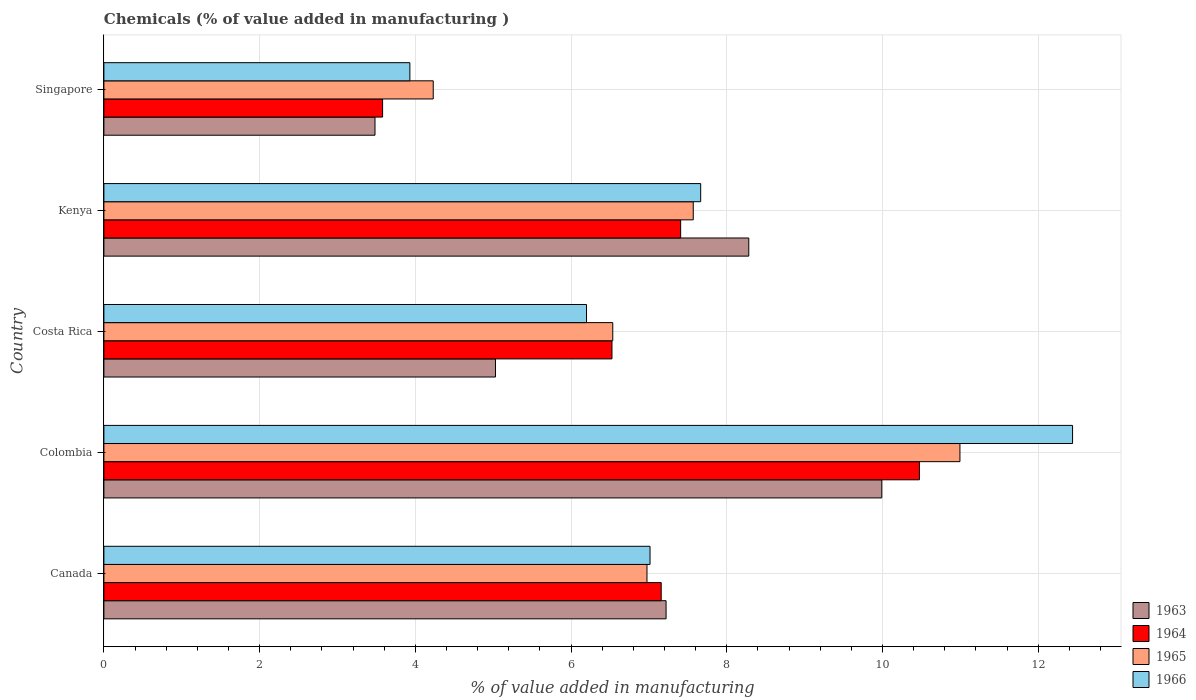How many different coloured bars are there?
Your answer should be very brief. 4. How many groups of bars are there?
Ensure brevity in your answer.  5. Are the number of bars per tick equal to the number of legend labels?
Provide a succinct answer. Yes. How many bars are there on the 5th tick from the bottom?
Offer a very short reply. 4. What is the label of the 1st group of bars from the top?
Provide a short and direct response. Singapore. In how many cases, is the number of bars for a given country not equal to the number of legend labels?
Provide a short and direct response. 0. What is the value added in manufacturing chemicals in 1964 in Canada?
Your response must be concise. 7.16. Across all countries, what is the maximum value added in manufacturing chemicals in 1965?
Keep it short and to the point. 10.99. Across all countries, what is the minimum value added in manufacturing chemicals in 1965?
Your answer should be very brief. 4.23. In which country was the value added in manufacturing chemicals in 1963 minimum?
Provide a succinct answer. Singapore. What is the total value added in manufacturing chemicals in 1965 in the graph?
Your answer should be very brief. 36.31. What is the difference between the value added in manufacturing chemicals in 1966 in Canada and that in Kenya?
Your answer should be very brief. -0.65. What is the difference between the value added in manufacturing chemicals in 1966 in Kenya and the value added in manufacturing chemicals in 1965 in Canada?
Your answer should be very brief. 0.69. What is the average value added in manufacturing chemicals in 1965 per country?
Your answer should be compact. 7.26. What is the difference between the value added in manufacturing chemicals in 1965 and value added in manufacturing chemicals in 1966 in Kenya?
Your response must be concise. -0.1. What is the ratio of the value added in manufacturing chemicals in 1966 in Canada to that in Colombia?
Offer a terse response. 0.56. Is the value added in manufacturing chemicals in 1964 in Canada less than that in Costa Rica?
Provide a succinct answer. No. What is the difference between the highest and the second highest value added in manufacturing chemicals in 1963?
Offer a very short reply. 1.71. What is the difference between the highest and the lowest value added in manufacturing chemicals in 1963?
Provide a short and direct response. 6.51. Is it the case that in every country, the sum of the value added in manufacturing chemicals in 1965 and value added in manufacturing chemicals in 1963 is greater than the sum of value added in manufacturing chemicals in 1964 and value added in manufacturing chemicals in 1966?
Your answer should be very brief. No. What does the 2nd bar from the top in Costa Rica represents?
Keep it short and to the point. 1965. What does the 1st bar from the bottom in Kenya represents?
Your answer should be compact. 1963. Are all the bars in the graph horizontal?
Offer a terse response. Yes. What is the difference between two consecutive major ticks on the X-axis?
Your answer should be very brief. 2. Are the values on the major ticks of X-axis written in scientific E-notation?
Provide a short and direct response. No. Does the graph contain any zero values?
Give a very brief answer. No. Where does the legend appear in the graph?
Your response must be concise. Bottom right. How are the legend labels stacked?
Make the answer very short. Vertical. What is the title of the graph?
Give a very brief answer. Chemicals (% of value added in manufacturing ). Does "1999" appear as one of the legend labels in the graph?
Provide a succinct answer. No. What is the label or title of the X-axis?
Provide a succinct answer. % of value added in manufacturing. What is the % of value added in manufacturing in 1963 in Canada?
Offer a very short reply. 7.22. What is the % of value added in manufacturing of 1964 in Canada?
Provide a short and direct response. 7.16. What is the % of value added in manufacturing of 1965 in Canada?
Your response must be concise. 6.98. What is the % of value added in manufacturing in 1966 in Canada?
Your response must be concise. 7.01. What is the % of value added in manufacturing in 1963 in Colombia?
Offer a terse response. 9.99. What is the % of value added in manufacturing in 1964 in Colombia?
Give a very brief answer. 10.47. What is the % of value added in manufacturing in 1965 in Colombia?
Offer a terse response. 10.99. What is the % of value added in manufacturing of 1966 in Colombia?
Offer a terse response. 12.44. What is the % of value added in manufacturing of 1963 in Costa Rica?
Ensure brevity in your answer.  5.03. What is the % of value added in manufacturing in 1964 in Costa Rica?
Offer a terse response. 6.53. What is the % of value added in manufacturing in 1965 in Costa Rica?
Your response must be concise. 6.54. What is the % of value added in manufacturing in 1966 in Costa Rica?
Your answer should be compact. 6.2. What is the % of value added in manufacturing in 1963 in Kenya?
Offer a terse response. 8.28. What is the % of value added in manufacturing of 1964 in Kenya?
Provide a succinct answer. 7.41. What is the % of value added in manufacturing in 1965 in Kenya?
Provide a succinct answer. 7.57. What is the % of value added in manufacturing of 1966 in Kenya?
Make the answer very short. 7.67. What is the % of value added in manufacturing of 1963 in Singapore?
Provide a short and direct response. 3.48. What is the % of value added in manufacturing in 1964 in Singapore?
Your response must be concise. 3.58. What is the % of value added in manufacturing of 1965 in Singapore?
Provide a short and direct response. 4.23. What is the % of value added in manufacturing of 1966 in Singapore?
Keep it short and to the point. 3.93. Across all countries, what is the maximum % of value added in manufacturing of 1963?
Make the answer very short. 9.99. Across all countries, what is the maximum % of value added in manufacturing in 1964?
Your answer should be very brief. 10.47. Across all countries, what is the maximum % of value added in manufacturing in 1965?
Keep it short and to the point. 10.99. Across all countries, what is the maximum % of value added in manufacturing in 1966?
Make the answer very short. 12.44. Across all countries, what is the minimum % of value added in manufacturing of 1963?
Your response must be concise. 3.48. Across all countries, what is the minimum % of value added in manufacturing of 1964?
Offer a terse response. 3.58. Across all countries, what is the minimum % of value added in manufacturing of 1965?
Your answer should be compact. 4.23. Across all countries, what is the minimum % of value added in manufacturing in 1966?
Give a very brief answer. 3.93. What is the total % of value added in manufacturing of 1963 in the graph?
Offer a very short reply. 34.01. What is the total % of value added in manufacturing in 1964 in the graph?
Your answer should be very brief. 35.15. What is the total % of value added in manufacturing of 1965 in the graph?
Offer a terse response. 36.31. What is the total % of value added in manufacturing in 1966 in the graph?
Provide a short and direct response. 37.25. What is the difference between the % of value added in manufacturing of 1963 in Canada and that in Colombia?
Your answer should be compact. -2.77. What is the difference between the % of value added in manufacturing of 1964 in Canada and that in Colombia?
Your answer should be compact. -3.32. What is the difference between the % of value added in manufacturing in 1965 in Canada and that in Colombia?
Make the answer very short. -4.02. What is the difference between the % of value added in manufacturing of 1966 in Canada and that in Colombia?
Provide a succinct answer. -5.43. What is the difference between the % of value added in manufacturing of 1963 in Canada and that in Costa Rica?
Keep it short and to the point. 2.19. What is the difference between the % of value added in manufacturing of 1964 in Canada and that in Costa Rica?
Your answer should be compact. 0.63. What is the difference between the % of value added in manufacturing of 1965 in Canada and that in Costa Rica?
Make the answer very short. 0.44. What is the difference between the % of value added in manufacturing of 1966 in Canada and that in Costa Rica?
Keep it short and to the point. 0.82. What is the difference between the % of value added in manufacturing of 1963 in Canada and that in Kenya?
Your response must be concise. -1.06. What is the difference between the % of value added in manufacturing of 1964 in Canada and that in Kenya?
Make the answer very short. -0.25. What is the difference between the % of value added in manufacturing of 1965 in Canada and that in Kenya?
Your answer should be very brief. -0.59. What is the difference between the % of value added in manufacturing in 1966 in Canada and that in Kenya?
Your answer should be very brief. -0.65. What is the difference between the % of value added in manufacturing in 1963 in Canada and that in Singapore?
Offer a terse response. 3.74. What is the difference between the % of value added in manufacturing of 1964 in Canada and that in Singapore?
Provide a short and direct response. 3.58. What is the difference between the % of value added in manufacturing in 1965 in Canada and that in Singapore?
Offer a very short reply. 2.75. What is the difference between the % of value added in manufacturing in 1966 in Canada and that in Singapore?
Make the answer very short. 3.08. What is the difference between the % of value added in manufacturing of 1963 in Colombia and that in Costa Rica?
Offer a terse response. 4.96. What is the difference between the % of value added in manufacturing of 1964 in Colombia and that in Costa Rica?
Your answer should be very brief. 3.95. What is the difference between the % of value added in manufacturing of 1965 in Colombia and that in Costa Rica?
Make the answer very short. 4.46. What is the difference between the % of value added in manufacturing in 1966 in Colombia and that in Costa Rica?
Your answer should be compact. 6.24. What is the difference between the % of value added in manufacturing of 1963 in Colombia and that in Kenya?
Offer a very short reply. 1.71. What is the difference between the % of value added in manufacturing of 1964 in Colombia and that in Kenya?
Offer a terse response. 3.07. What is the difference between the % of value added in manufacturing in 1965 in Colombia and that in Kenya?
Provide a succinct answer. 3.43. What is the difference between the % of value added in manufacturing in 1966 in Colombia and that in Kenya?
Offer a terse response. 4.78. What is the difference between the % of value added in manufacturing in 1963 in Colombia and that in Singapore?
Provide a succinct answer. 6.51. What is the difference between the % of value added in manufacturing of 1964 in Colombia and that in Singapore?
Your answer should be very brief. 6.89. What is the difference between the % of value added in manufacturing of 1965 in Colombia and that in Singapore?
Give a very brief answer. 6.76. What is the difference between the % of value added in manufacturing of 1966 in Colombia and that in Singapore?
Offer a terse response. 8.51. What is the difference between the % of value added in manufacturing in 1963 in Costa Rica and that in Kenya?
Give a very brief answer. -3.25. What is the difference between the % of value added in manufacturing in 1964 in Costa Rica and that in Kenya?
Your answer should be compact. -0.88. What is the difference between the % of value added in manufacturing in 1965 in Costa Rica and that in Kenya?
Make the answer very short. -1.03. What is the difference between the % of value added in manufacturing of 1966 in Costa Rica and that in Kenya?
Your answer should be compact. -1.47. What is the difference between the % of value added in manufacturing of 1963 in Costa Rica and that in Singapore?
Offer a very short reply. 1.55. What is the difference between the % of value added in manufacturing of 1964 in Costa Rica and that in Singapore?
Keep it short and to the point. 2.95. What is the difference between the % of value added in manufacturing of 1965 in Costa Rica and that in Singapore?
Provide a succinct answer. 2.31. What is the difference between the % of value added in manufacturing in 1966 in Costa Rica and that in Singapore?
Make the answer very short. 2.27. What is the difference between the % of value added in manufacturing of 1963 in Kenya and that in Singapore?
Your answer should be compact. 4.8. What is the difference between the % of value added in manufacturing of 1964 in Kenya and that in Singapore?
Ensure brevity in your answer.  3.83. What is the difference between the % of value added in manufacturing in 1965 in Kenya and that in Singapore?
Ensure brevity in your answer.  3.34. What is the difference between the % of value added in manufacturing in 1966 in Kenya and that in Singapore?
Offer a very short reply. 3.74. What is the difference between the % of value added in manufacturing of 1963 in Canada and the % of value added in manufacturing of 1964 in Colombia?
Provide a succinct answer. -3.25. What is the difference between the % of value added in manufacturing of 1963 in Canada and the % of value added in manufacturing of 1965 in Colombia?
Offer a terse response. -3.77. What is the difference between the % of value added in manufacturing in 1963 in Canada and the % of value added in manufacturing in 1966 in Colombia?
Provide a succinct answer. -5.22. What is the difference between the % of value added in manufacturing of 1964 in Canada and the % of value added in manufacturing of 1965 in Colombia?
Provide a short and direct response. -3.84. What is the difference between the % of value added in manufacturing in 1964 in Canada and the % of value added in manufacturing in 1966 in Colombia?
Your response must be concise. -5.28. What is the difference between the % of value added in manufacturing in 1965 in Canada and the % of value added in manufacturing in 1966 in Colombia?
Ensure brevity in your answer.  -5.47. What is the difference between the % of value added in manufacturing in 1963 in Canada and the % of value added in manufacturing in 1964 in Costa Rica?
Your response must be concise. 0.69. What is the difference between the % of value added in manufacturing of 1963 in Canada and the % of value added in manufacturing of 1965 in Costa Rica?
Make the answer very short. 0.68. What is the difference between the % of value added in manufacturing of 1963 in Canada and the % of value added in manufacturing of 1966 in Costa Rica?
Give a very brief answer. 1.02. What is the difference between the % of value added in manufacturing of 1964 in Canada and the % of value added in manufacturing of 1965 in Costa Rica?
Provide a short and direct response. 0.62. What is the difference between the % of value added in manufacturing of 1964 in Canada and the % of value added in manufacturing of 1966 in Costa Rica?
Provide a short and direct response. 0.96. What is the difference between the % of value added in manufacturing in 1965 in Canada and the % of value added in manufacturing in 1966 in Costa Rica?
Offer a terse response. 0.78. What is the difference between the % of value added in manufacturing of 1963 in Canada and the % of value added in manufacturing of 1964 in Kenya?
Your answer should be compact. -0.19. What is the difference between the % of value added in manufacturing of 1963 in Canada and the % of value added in manufacturing of 1965 in Kenya?
Provide a short and direct response. -0.35. What is the difference between the % of value added in manufacturing of 1963 in Canada and the % of value added in manufacturing of 1966 in Kenya?
Provide a succinct answer. -0.44. What is the difference between the % of value added in manufacturing in 1964 in Canada and the % of value added in manufacturing in 1965 in Kenya?
Your answer should be compact. -0.41. What is the difference between the % of value added in manufacturing of 1964 in Canada and the % of value added in manufacturing of 1966 in Kenya?
Provide a short and direct response. -0.51. What is the difference between the % of value added in manufacturing in 1965 in Canada and the % of value added in manufacturing in 1966 in Kenya?
Give a very brief answer. -0.69. What is the difference between the % of value added in manufacturing in 1963 in Canada and the % of value added in manufacturing in 1964 in Singapore?
Your response must be concise. 3.64. What is the difference between the % of value added in manufacturing of 1963 in Canada and the % of value added in manufacturing of 1965 in Singapore?
Ensure brevity in your answer.  2.99. What is the difference between the % of value added in manufacturing of 1963 in Canada and the % of value added in manufacturing of 1966 in Singapore?
Keep it short and to the point. 3.29. What is the difference between the % of value added in manufacturing in 1964 in Canada and the % of value added in manufacturing in 1965 in Singapore?
Give a very brief answer. 2.93. What is the difference between the % of value added in manufacturing of 1964 in Canada and the % of value added in manufacturing of 1966 in Singapore?
Ensure brevity in your answer.  3.23. What is the difference between the % of value added in manufacturing of 1965 in Canada and the % of value added in manufacturing of 1966 in Singapore?
Ensure brevity in your answer.  3.05. What is the difference between the % of value added in manufacturing of 1963 in Colombia and the % of value added in manufacturing of 1964 in Costa Rica?
Ensure brevity in your answer.  3.47. What is the difference between the % of value added in manufacturing of 1963 in Colombia and the % of value added in manufacturing of 1965 in Costa Rica?
Ensure brevity in your answer.  3.46. What is the difference between the % of value added in manufacturing of 1963 in Colombia and the % of value added in manufacturing of 1966 in Costa Rica?
Keep it short and to the point. 3.79. What is the difference between the % of value added in manufacturing of 1964 in Colombia and the % of value added in manufacturing of 1965 in Costa Rica?
Offer a terse response. 3.94. What is the difference between the % of value added in manufacturing in 1964 in Colombia and the % of value added in manufacturing in 1966 in Costa Rica?
Keep it short and to the point. 4.28. What is the difference between the % of value added in manufacturing in 1965 in Colombia and the % of value added in manufacturing in 1966 in Costa Rica?
Give a very brief answer. 4.8. What is the difference between the % of value added in manufacturing in 1963 in Colombia and the % of value added in manufacturing in 1964 in Kenya?
Your response must be concise. 2.58. What is the difference between the % of value added in manufacturing in 1963 in Colombia and the % of value added in manufacturing in 1965 in Kenya?
Give a very brief answer. 2.42. What is the difference between the % of value added in manufacturing in 1963 in Colombia and the % of value added in manufacturing in 1966 in Kenya?
Your answer should be very brief. 2.33. What is the difference between the % of value added in manufacturing of 1964 in Colombia and the % of value added in manufacturing of 1965 in Kenya?
Your response must be concise. 2.9. What is the difference between the % of value added in manufacturing in 1964 in Colombia and the % of value added in manufacturing in 1966 in Kenya?
Ensure brevity in your answer.  2.81. What is the difference between the % of value added in manufacturing in 1965 in Colombia and the % of value added in manufacturing in 1966 in Kenya?
Make the answer very short. 3.33. What is the difference between the % of value added in manufacturing in 1963 in Colombia and the % of value added in manufacturing in 1964 in Singapore?
Give a very brief answer. 6.41. What is the difference between the % of value added in manufacturing of 1963 in Colombia and the % of value added in manufacturing of 1965 in Singapore?
Provide a short and direct response. 5.76. What is the difference between the % of value added in manufacturing in 1963 in Colombia and the % of value added in manufacturing in 1966 in Singapore?
Keep it short and to the point. 6.06. What is the difference between the % of value added in manufacturing in 1964 in Colombia and the % of value added in manufacturing in 1965 in Singapore?
Offer a very short reply. 6.24. What is the difference between the % of value added in manufacturing of 1964 in Colombia and the % of value added in manufacturing of 1966 in Singapore?
Your answer should be compact. 6.54. What is the difference between the % of value added in manufacturing of 1965 in Colombia and the % of value added in manufacturing of 1966 in Singapore?
Your response must be concise. 7.07. What is the difference between the % of value added in manufacturing in 1963 in Costa Rica and the % of value added in manufacturing in 1964 in Kenya?
Your answer should be compact. -2.38. What is the difference between the % of value added in manufacturing of 1963 in Costa Rica and the % of value added in manufacturing of 1965 in Kenya?
Provide a succinct answer. -2.54. What is the difference between the % of value added in manufacturing in 1963 in Costa Rica and the % of value added in manufacturing in 1966 in Kenya?
Ensure brevity in your answer.  -2.64. What is the difference between the % of value added in manufacturing of 1964 in Costa Rica and the % of value added in manufacturing of 1965 in Kenya?
Offer a very short reply. -1.04. What is the difference between the % of value added in manufacturing of 1964 in Costa Rica and the % of value added in manufacturing of 1966 in Kenya?
Your answer should be very brief. -1.14. What is the difference between the % of value added in manufacturing of 1965 in Costa Rica and the % of value added in manufacturing of 1966 in Kenya?
Offer a very short reply. -1.13. What is the difference between the % of value added in manufacturing of 1963 in Costa Rica and the % of value added in manufacturing of 1964 in Singapore?
Provide a succinct answer. 1.45. What is the difference between the % of value added in manufacturing in 1963 in Costa Rica and the % of value added in manufacturing in 1965 in Singapore?
Ensure brevity in your answer.  0.8. What is the difference between the % of value added in manufacturing of 1963 in Costa Rica and the % of value added in manufacturing of 1966 in Singapore?
Offer a terse response. 1.1. What is the difference between the % of value added in manufacturing in 1964 in Costa Rica and the % of value added in manufacturing in 1965 in Singapore?
Make the answer very short. 2.3. What is the difference between the % of value added in manufacturing of 1964 in Costa Rica and the % of value added in manufacturing of 1966 in Singapore?
Make the answer very short. 2.6. What is the difference between the % of value added in manufacturing of 1965 in Costa Rica and the % of value added in manufacturing of 1966 in Singapore?
Keep it short and to the point. 2.61. What is the difference between the % of value added in manufacturing of 1963 in Kenya and the % of value added in manufacturing of 1964 in Singapore?
Give a very brief answer. 4.7. What is the difference between the % of value added in manufacturing of 1963 in Kenya and the % of value added in manufacturing of 1965 in Singapore?
Give a very brief answer. 4.05. What is the difference between the % of value added in manufacturing of 1963 in Kenya and the % of value added in manufacturing of 1966 in Singapore?
Your answer should be compact. 4.35. What is the difference between the % of value added in manufacturing in 1964 in Kenya and the % of value added in manufacturing in 1965 in Singapore?
Provide a succinct answer. 3.18. What is the difference between the % of value added in manufacturing of 1964 in Kenya and the % of value added in manufacturing of 1966 in Singapore?
Your response must be concise. 3.48. What is the difference between the % of value added in manufacturing of 1965 in Kenya and the % of value added in manufacturing of 1966 in Singapore?
Your response must be concise. 3.64. What is the average % of value added in manufacturing in 1963 per country?
Provide a succinct answer. 6.8. What is the average % of value added in manufacturing of 1964 per country?
Give a very brief answer. 7.03. What is the average % of value added in manufacturing in 1965 per country?
Your answer should be very brief. 7.26. What is the average % of value added in manufacturing of 1966 per country?
Provide a succinct answer. 7.45. What is the difference between the % of value added in manufacturing of 1963 and % of value added in manufacturing of 1964 in Canada?
Your answer should be compact. 0.06. What is the difference between the % of value added in manufacturing of 1963 and % of value added in manufacturing of 1965 in Canada?
Make the answer very short. 0.25. What is the difference between the % of value added in manufacturing in 1963 and % of value added in manufacturing in 1966 in Canada?
Keep it short and to the point. 0.21. What is the difference between the % of value added in manufacturing in 1964 and % of value added in manufacturing in 1965 in Canada?
Your response must be concise. 0.18. What is the difference between the % of value added in manufacturing in 1964 and % of value added in manufacturing in 1966 in Canada?
Your answer should be very brief. 0.14. What is the difference between the % of value added in manufacturing of 1965 and % of value added in manufacturing of 1966 in Canada?
Your answer should be compact. -0.04. What is the difference between the % of value added in manufacturing in 1963 and % of value added in manufacturing in 1964 in Colombia?
Provide a succinct answer. -0.48. What is the difference between the % of value added in manufacturing of 1963 and % of value added in manufacturing of 1965 in Colombia?
Offer a terse response. -1. What is the difference between the % of value added in manufacturing of 1963 and % of value added in manufacturing of 1966 in Colombia?
Offer a terse response. -2.45. What is the difference between the % of value added in manufacturing in 1964 and % of value added in manufacturing in 1965 in Colombia?
Offer a very short reply. -0.52. What is the difference between the % of value added in manufacturing of 1964 and % of value added in manufacturing of 1966 in Colombia?
Your answer should be very brief. -1.97. What is the difference between the % of value added in manufacturing in 1965 and % of value added in manufacturing in 1966 in Colombia?
Your answer should be compact. -1.45. What is the difference between the % of value added in manufacturing in 1963 and % of value added in manufacturing in 1964 in Costa Rica?
Offer a very short reply. -1.5. What is the difference between the % of value added in manufacturing of 1963 and % of value added in manufacturing of 1965 in Costa Rica?
Ensure brevity in your answer.  -1.51. What is the difference between the % of value added in manufacturing of 1963 and % of value added in manufacturing of 1966 in Costa Rica?
Give a very brief answer. -1.17. What is the difference between the % of value added in manufacturing in 1964 and % of value added in manufacturing in 1965 in Costa Rica?
Your answer should be very brief. -0.01. What is the difference between the % of value added in manufacturing of 1964 and % of value added in manufacturing of 1966 in Costa Rica?
Offer a very short reply. 0.33. What is the difference between the % of value added in manufacturing in 1965 and % of value added in manufacturing in 1966 in Costa Rica?
Keep it short and to the point. 0.34. What is the difference between the % of value added in manufacturing of 1963 and % of value added in manufacturing of 1964 in Kenya?
Offer a very short reply. 0.87. What is the difference between the % of value added in manufacturing in 1963 and % of value added in manufacturing in 1965 in Kenya?
Your response must be concise. 0.71. What is the difference between the % of value added in manufacturing of 1963 and % of value added in manufacturing of 1966 in Kenya?
Offer a terse response. 0.62. What is the difference between the % of value added in manufacturing of 1964 and % of value added in manufacturing of 1965 in Kenya?
Make the answer very short. -0.16. What is the difference between the % of value added in manufacturing of 1964 and % of value added in manufacturing of 1966 in Kenya?
Offer a very short reply. -0.26. What is the difference between the % of value added in manufacturing of 1965 and % of value added in manufacturing of 1966 in Kenya?
Provide a succinct answer. -0.1. What is the difference between the % of value added in manufacturing of 1963 and % of value added in manufacturing of 1964 in Singapore?
Your answer should be very brief. -0.1. What is the difference between the % of value added in manufacturing in 1963 and % of value added in manufacturing in 1965 in Singapore?
Provide a short and direct response. -0.75. What is the difference between the % of value added in manufacturing in 1963 and % of value added in manufacturing in 1966 in Singapore?
Provide a succinct answer. -0.45. What is the difference between the % of value added in manufacturing in 1964 and % of value added in manufacturing in 1965 in Singapore?
Offer a terse response. -0.65. What is the difference between the % of value added in manufacturing of 1964 and % of value added in manufacturing of 1966 in Singapore?
Your response must be concise. -0.35. What is the difference between the % of value added in manufacturing in 1965 and % of value added in manufacturing in 1966 in Singapore?
Your response must be concise. 0.3. What is the ratio of the % of value added in manufacturing of 1963 in Canada to that in Colombia?
Offer a very short reply. 0.72. What is the ratio of the % of value added in manufacturing in 1964 in Canada to that in Colombia?
Provide a short and direct response. 0.68. What is the ratio of the % of value added in manufacturing in 1965 in Canada to that in Colombia?
Your answer should be very brief. 0.63. What is the ratio of the % of value added in manufacturing in 1966 in Canada to that in Colombia?
Keep it short and to the point. 0.56. What is the ratio of the % of value added in manufacturing in 1963 in Canada to that in Costa Rica?
Give a very brief answer. 1.44. What is the ratio of the % of value added in manufacturing of 1964 in Canada to that in Costa Rica?
Ensure brevity in your answer.  1.1. What is the ratio of the % of value added in manufacturing of 1965 in Canada to that in Costa Rica?
Ensure brevity in your answer.  1.07. What is the ratio of the % of value added in manufacturing of 1966 in Canada to that in Costa Rica?
Offer a very short reply. 1.13. What is the ratio of the % of value added in manufacturing in 1963 in Canada to that in Kenya?
Offer a terse response. 0.87. What is the ratio of the % of value added in manufacturing of 1964 in Canada to that in Kenya?
Your answer should be very brief. 0.97. What is the ratio of the % of value added in manufacturing in 1965 in Canada to that in Kenya?
Provide a short and direct response. 0.92. What is the ratio of the % of value added in manufacturing of 1966 in Canada to that in Kenya?
Make the answer very short. 0.92. What is the ratio of the % of value added in manufacturing of 1963 in Canada to that in Singapore?
Make the answer very short. 2.07. What is the ratio of the % of value added in manufacturing in 1964 in Canada to that in Singapore?
Give a very brief answer. 2. What is the ratio of the % of value added in manufacturing in 1965 in Canada to that in Singapore?
Provide a succinct answer. 1.65. What is the ratio of the % of value added in manufacturing of 1966 in Canada to that in Singapore?
Ensure brevity in your answer.  1.78. What is the ratio of the % of value added in manufacturing of 1963 in Colombia to that in Costa Rica?
Your answer should be very brief. 1.99. What is the ratio of the % of value added in manufacturing in 1964 in Colombia to that in Costa Rica?
Ensure brevity in your answer.  1.61. What is the ratio of the % of value added in manufacturing of 1965 in Colombia to that in Costa Rica?
Your answer should be compact. 1.68. What is the ratio of the % of value added in manufacturing of 1966 in Colombia to that in Costa Rica?
Provide a succinct answer. 2.01. What is the ratio of the % of value added in manufacturing of 1963 in Colombia to that in Kenya?
Ensure brevity in your answer.  1.21. What is the ratio of the % of value added in manufacturing in 1964 in Colombia to that in Kenya?
Your response must be concise. 1.41. What is the ratio of the % of value added in manufacturing of 1965 in Colombia to that in Kenya?
Offer a terse response. 1.45. What is the ratio of the % of value added in manufacturing of 1966 in Colombia to that in Kenya?
Offer a terse response. 1.62. What is the ratio of the % of value added in manufacturing in 1963 in Colombia to that in Singapore?
Offer a terse response. 2.87. What is the ratio of the % of value added in manufacturing of 1964 in Colombia to that in Singapore?
Provide a short and direct response. 2.93. What is the ratio of the % of value added in manufacturing in 1965 in Colombia to that in Singapore?
Your answer should be compact. 2.6. What is the ratio of the % of value added in manufacturing in 1966 in Colombia to that in Singapore?
Give a very brief answer. 3.17. What is the ratio of the % of value added in manufacturing in 1963 in Costa Rica to that in Kenya?
Keep it short and to the point. 0.61. What is the ratio of the % of value added in manufacturing of 1964 in Costa Rica to that in Kenya?
Ensure brevity in your answer.  0.88. What is the ratio of the % of value added in manufacturing in 1965 in Costa Rica to that in Kenya?
Make the answer very short. 0.86. What is the ratio of the % of value added in manufacturing in 1966 in Costa Rica to that in Kenya?
Ensure brevity in your answer.  0.81. What is the ratio of the % of value added in manufacturing of 1963 in Costa Rica to that in Singapore?
Your answer should be very brief. 1.44. What is the ratio of the % of value added in manufacturing of 1964 in Costa Rica to that in Singapore?
Your response must be concise. 1.82. What is the ratio of the % of value added in manufacturing of 1965 in Costa Rica to that in Singapore?
Ensure brevity in your answer.  1.55. What is the ratio of the % of value added in manufacturing of 1966 in Costa Rica to that in Singapore?
Ensure brevity in your answer.  1.58. What is the ratio of the % of value added in manufacturing in 1963 in Kenya to that in Singapore?
Your answer should be compact. 2.38. What is the ratio of the % of value added in manufacturing of 1964 in Kenya to that in Singapore?
Provide a succinct answer. 2.07. What is the ratio of the % of value added in manufacturing in 1965 in Kenya to that in Singapore?
Provide a succinct answer. 1.79. What is the ratio of the % of value added in manufacturing of 1966 in Kenya to that in Singapore?
Provide a short and direct response. 1.95. What is the difference between the highest and the second highest % of value added in manufacturing in 1963?
Provide a succinct answer. 1.71. What is the difference between the highest and the second highest % of value added in manufacturing in 1964?
Provide a succinct answer. 3.07. What is the difference between the highest and the second highest % of value added in manufacturing of 1965?
Offer a very short reply. 3.43. What is the difference between the highest and the second highest % of value added in manufacturing in 1966?
Provide a short and direct response. 4.78. What is the difference between the highest and the lowest % of value added in manufacturing in 1963?
Your answer should be very brief. 6.51. What is the difference between the highest and the lowest % of value added in manufacturing of 1964?
Ensure brevity in your answer.  6.89. What is the difference between the highest and the lowest % of value added in manufacturing of 1965?
Make the answer very short. 6.76. What is the difference between the highest and the lowest % of value added in manufacturing in 1966?
Provide a short and direct response. 8.51. 